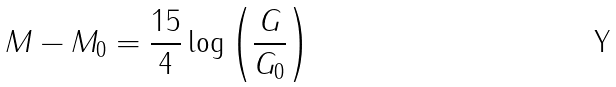Convert formula to latex. <formula><loc_0><loc_0><loc_500><loc_500>M - M _ { 0 } = \frac { 1 5 } { 4 } \log \left ( \frac { G } { G _ { 0 } } \right )</formula> 